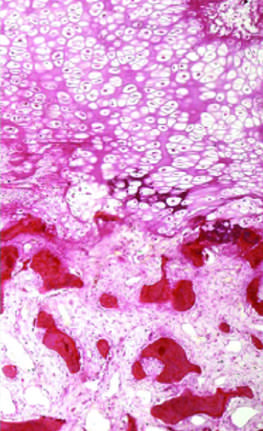do interstitial fibrosis and tubular atrophy consist of uncalcified osteoid?
Answer the question using a single word or phrase. No 